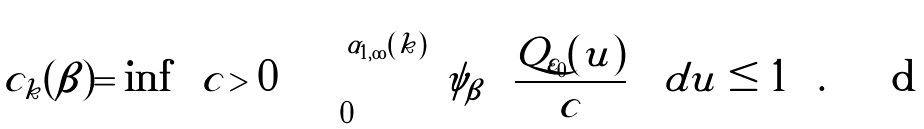<formula> <loc_0><loc_0><loc_500><loc_500>c _ { k } ( \beta ) = \inf \left \{ c > 0 \, \Big | \, \int _ { 0 } ^ { \alpha _ { 1 , \infty } ( | k | ) } \psi _ { \beta } \left ( \frac { Q _ { \varepsilon _ { 0 } } ( u ) } { c } \right ) \, d u \leq 1 \right \} .</formula> 